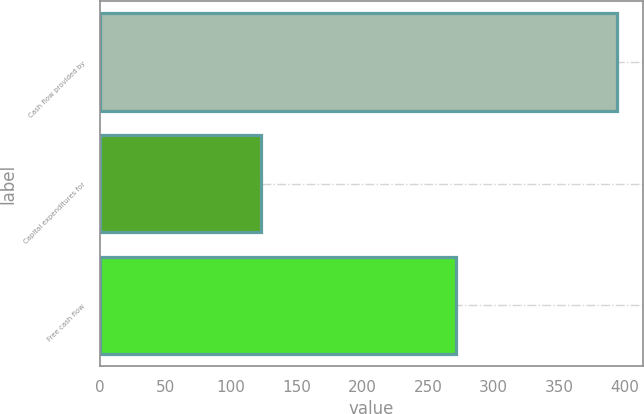Convert chart to OTSL. <chart><loc_0><loc_0><loc_500><loc_500><bar_chart><fcel>Cash flow provided by<fcel>Capital expenditures for<fcel>Free cash flow<nl><fcel>394.2<fcel>122.8<fcel>271.4<nl></chart> 